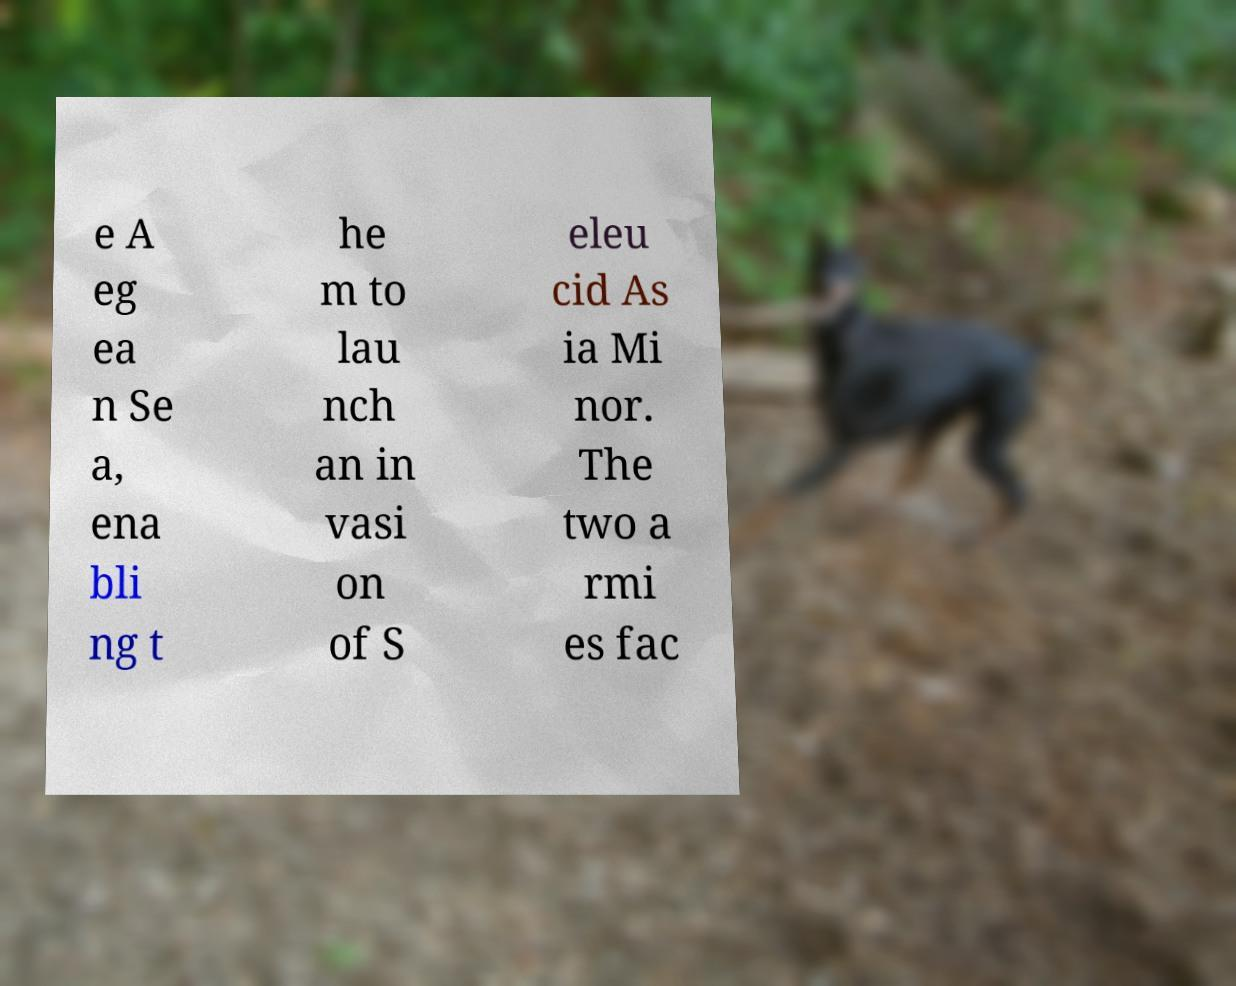For documentation purposes, I need the text within this image transcribed. Could you provide that? e A eg ea n Se a, ena bli ng t he m to lau nch an in vasi on of S eleu cid As ia Mi nor. The two a rmi es fac 